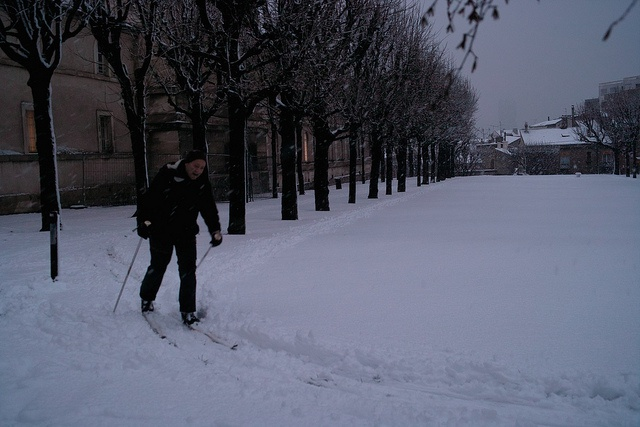Describe the objects in this image and their specific colors. I can see people in black and gray tones, backpack in black and gray tones, skis in black and gray tones, and people in black, gray, and darkblue tones in this image. 